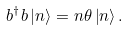Convert formula to latex. <formula><loc_0><loc_0><loc_500><loc_500>b ^ { \dagger } b \left | n \right \rangle = n \theta \left | n \right \rangle .</formula> 